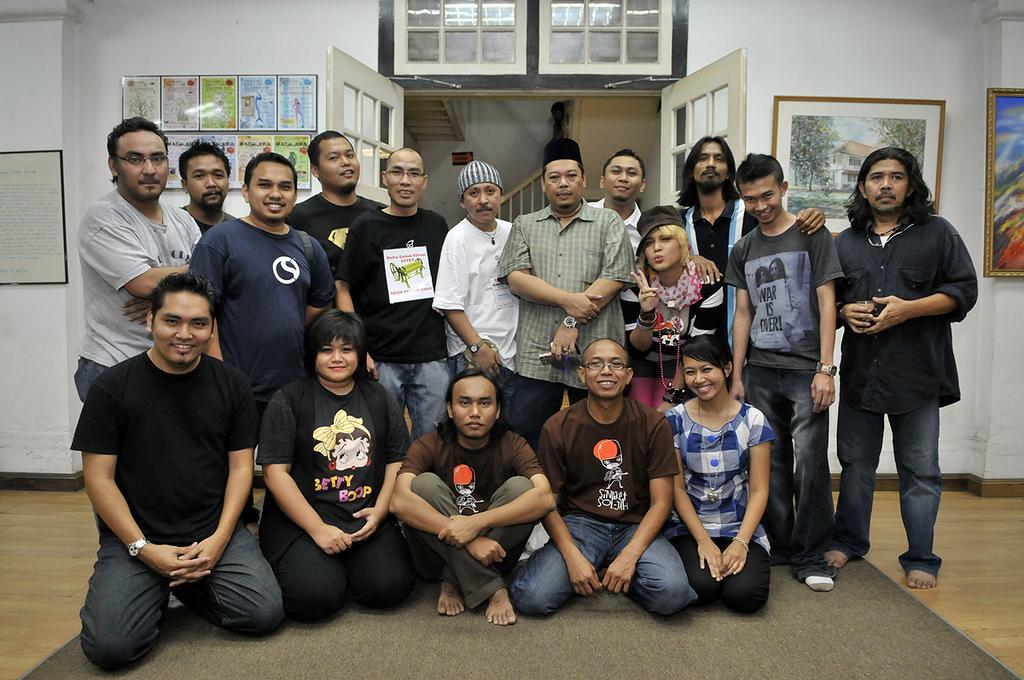Can you describe this image briefly? In this image we can see group of persons sitting and standing on the floor. In the background we can see photo frames, door, stairs and wall. 